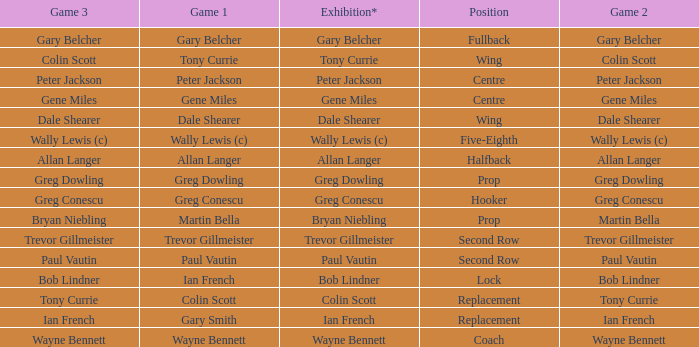Wjat game 3 has ian french as a game of 2? Ian French. 